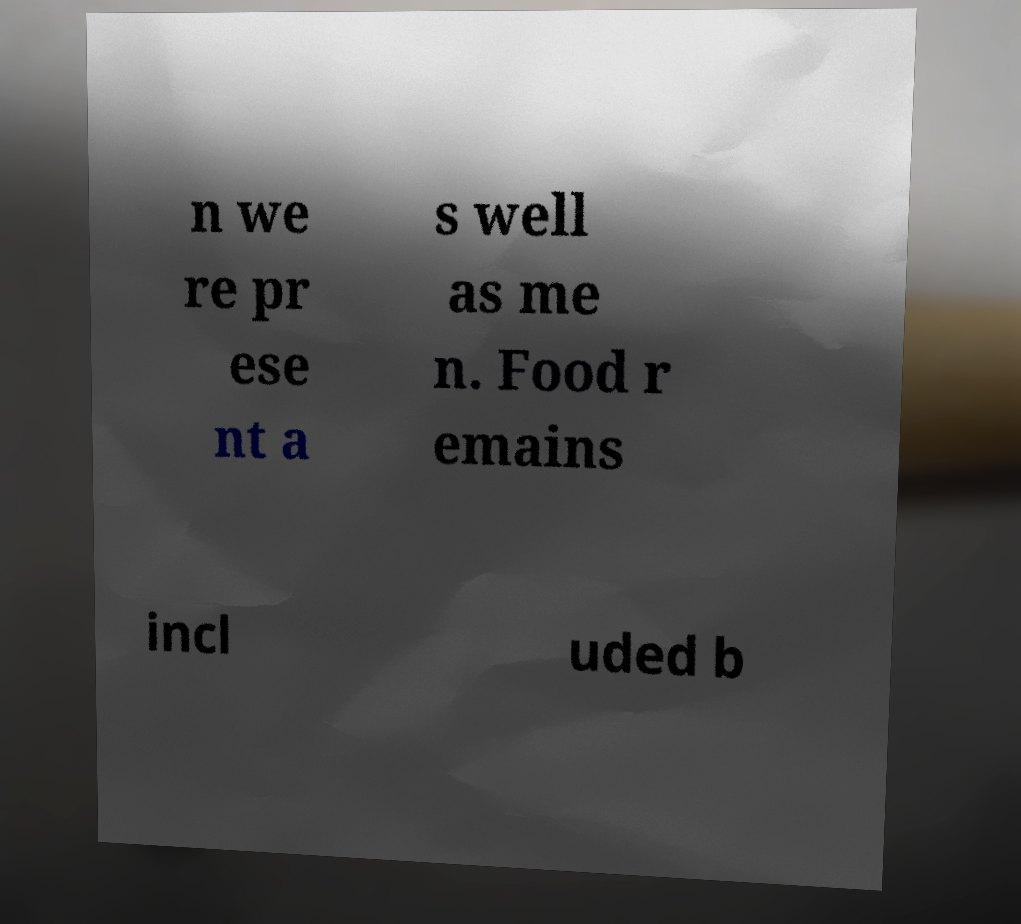What messages or text are displayed in this image? I need them in a readable, typed format. n we re pr ese nt a s well as me n. Food r emains incl uded b 